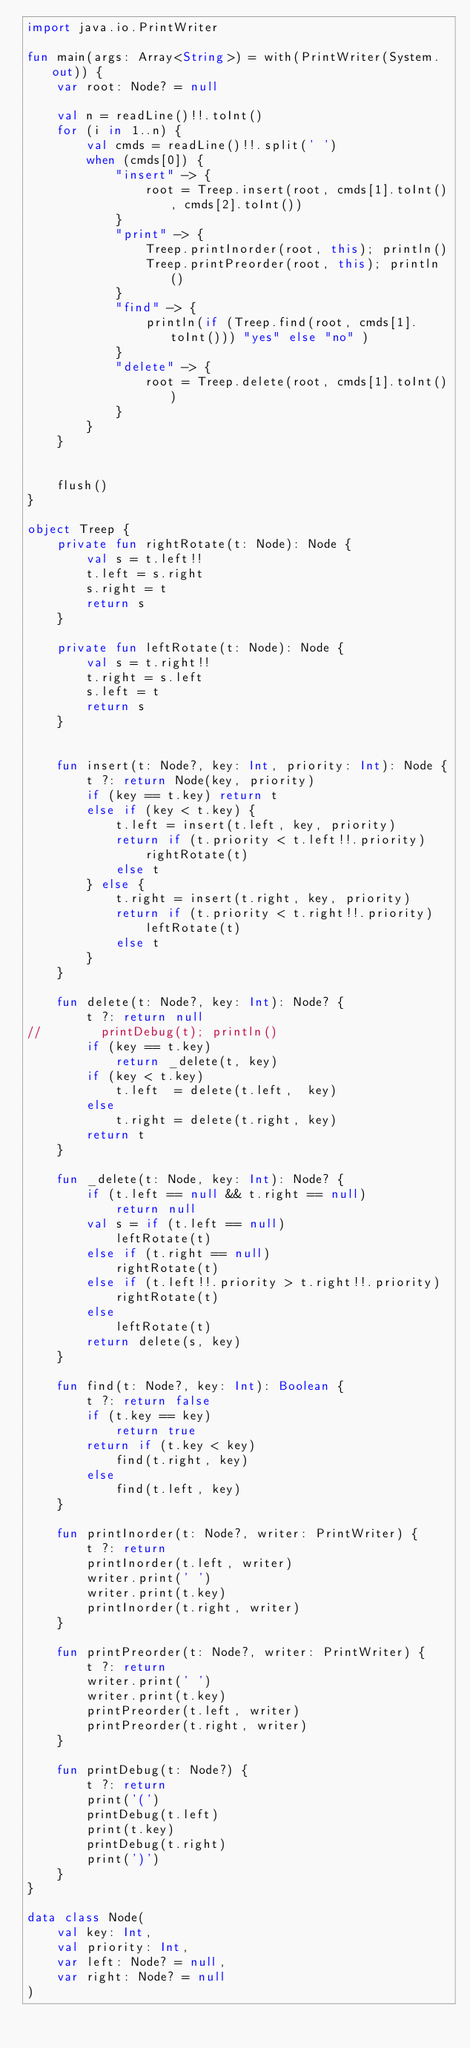<code> <loc_0><loc_0><loc_500><loc_500><_Kotlin_>import java.io.PrintWriter

fun main(args: Array<String>) = with(PrintWriter(System.out)) {
    var root: Node? = null

    val n = readLine()!!.toInt()
    for (i in 1..n) {
        val cmds = readLine()!!.split(' ')
        when (cmds[0]) {
            "insert" -> {
                root = Treep.insert(root, cmds[1].toInt(), cmds[2].toInt())
            }
            "print" -> {
                Treep.printInorder(root, this); println()
                Treep.printPreorder(root, this); println()
            }
            "find" -> {
                println(if (Treep.find(root, cmds[1].toInt())) "yes" else "no" )
            }
            "delete" -> {
                root = Treep.delete(root, cmds[1].toInt())
            }
        }
    }


    flush()
}

object Treep {
    private fun rightRotate(t: Node): Node {
        val s = t.left!!
        t.left = s.right
        s.right = t
        return s
    }

    private fun leftRotate(t: Node): Node {
        val s = t.right!!
        t.right = s.left
        s.left = t
        return s
    }


    fun insert(t: Node?, key: Int, priority: Int): Node {
        t ?: return Node(key, priority)
        if (key == t.key) return t
        else if (key < t.key) {
            t.left = insert(t.left, key, priority)
            return if (t.priority < t.left!!.priority)
                rightRotate(t)
            else t
        } else {
            t.right = insert(t.right, key, priority)
            return if (t.priority < t.right!!.priority)
                leftRotate(t)
            else t
        }
    }

    fun delete(t: Node?, key: Int): Node? {
        t ?: return null
//        printDebug(t); println()
        if (key == t.key)
            return _delete(t, key)
        if (key < t.key)
            t.left  = delete(t.left,  key)
        else
            t.right = delete(t.right, key)
        return t
    }

    fun _delete(t: Node, key: Int): Node? {
        if (t.left == null && t.right == null)
            return null
        val s = if (t.left == null)
            leftRotate(t)
        else if (t.right == null)
            rightRotate(t)
        else if (t.left!!.priority > t.right!!.priority)
            rightRotate(t)
        else
            leftRotate(t)
        return delete(s, key)
    }

    fun find(t: Node?, key: Int): Boolean {
        t ?: return false
        if (t.key == key)
            return true
        return if (t.key < key)
            find(t.right, key)
        else
            find(t.left, key)
    }

    fun printInorder(t: Node?, writer: PrintWriter) {
        t ?: return
        printInorder(t.left, writer)
        writer.print(' ')
        writer.print(t.key)
        printInorder(t.right, writer)
    }

    fun printPreorder(t: Node?, writer: PrintWriter) {
        t ?: return
        writer.print(' ')
        writer.print(t.key)
        printPreorder(t.left, writer)
        printPreorder(t.right, writer)
    }

    fun printDebug(t: Node?) {
        t ?: return
        print('(')
        printDebug(t.left)
        print(t.key)
        printDebug(t.right)
        print(')')
    }
}

data class Node(
    val key: Int,
    val priority: Int,
    var left: Node? = null,
    var right: Node? = null
)
</code> 